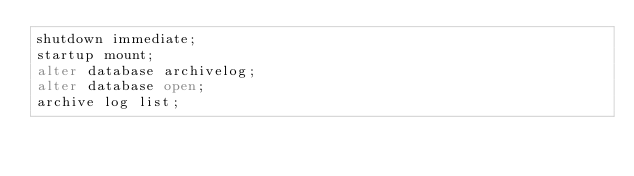<code> <loc_0><loc_0><loc_500><loc_500><_SQL_>shutdown immediate;
startup mount;
alter database archivelog;
alter database open;
archive log list;</code> 